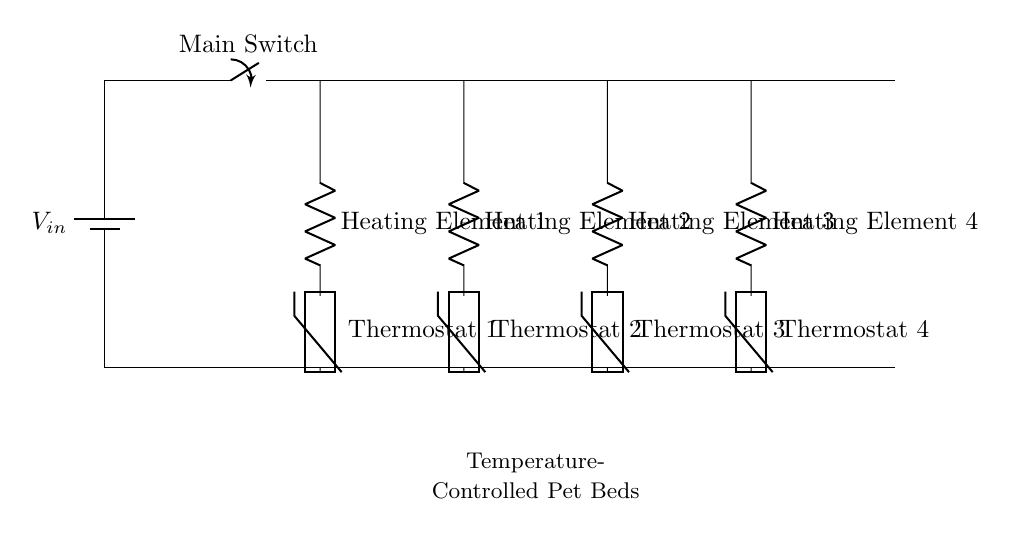What is the main component providing power in this circuit? The battery is the main component providing power, indicated by the symbol for a battery at the left side of the circuit.
Answer: battery How many heating elements are present in this circuit? There are four heating elements shown in the circuit, each represented by a resistor symbol labeled Heating Element 1 through Heating Element 4.
Answer: four What is the purpose of the thermistors in this circuit? The thermistors act as thermostats to measure and control the temperature of each heating element, ensuring the pet beds maintain the desired warmth.
Answer: temperature control What is the connection type of the heating elements in this circuit? The heating elements are connected in parallel, as each element has its own branch connected directly to the voltage source.
Answer: parallel Which element acts as a switch in this circuit? The main switch, labeled as "Main Switch," controls the flow of power to the entire circuit.
Answer: Main Switch What happens to the heating elements if one fails? If one heating element fails, the others will continue to operate since they are in parallel, allowing for independent functioning of each heating element.
Answer: continues to operate What additional component is needed for temperature regulation apart from the heating elements? The thermistors are necessary for temperature regulation, monitoring the bed's temperature and providing feedback for adjustments.
Answer: thermistors 